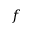<formula> <loc_0><loc_0><loc_500><loc_500>f</formula> 